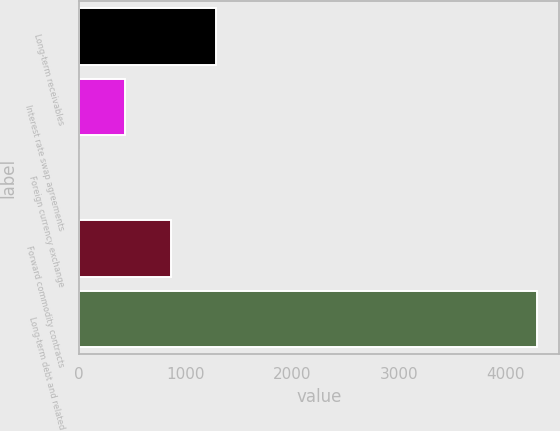Convert chart to OTSL. <chart><loc_0><loc_0><loc_500><loc_500><bar_chart><fcel>Long-term receivables<fcel>Interest rate swap agreements<fcel>Foreign currency exchange<fcel>Forward commodity contracts<fcel>Long-term debt and related<nl><fcel>1289.4<fcel>431.8<fcel>3<fcel>860.6<fcel>4291<nl></chart> 